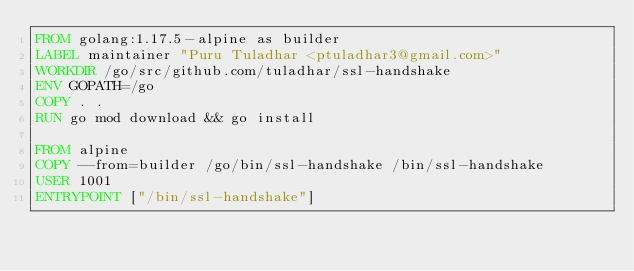Convert code to text. <code><loc_0><loc_0><loc_500><loc_500><_Dockerfile_>FROM golang:1.17.5-alpine as builder
LABEL maintainer "Puru Tuladhar <ptuladhar3@gmail.com>"
WORKDIR /go/src/github.com/tuladhar/ssl-handshake
ENV GOPATH=/go
COPY . .
RUN go mod download && go install

FROM alpine
COPY --from=builder /go/bin/ssl-handshake /bin/ssl-handshake
USER 1001
ENTRYPOINT ["/bin/ssl-handshake"]
</code> 